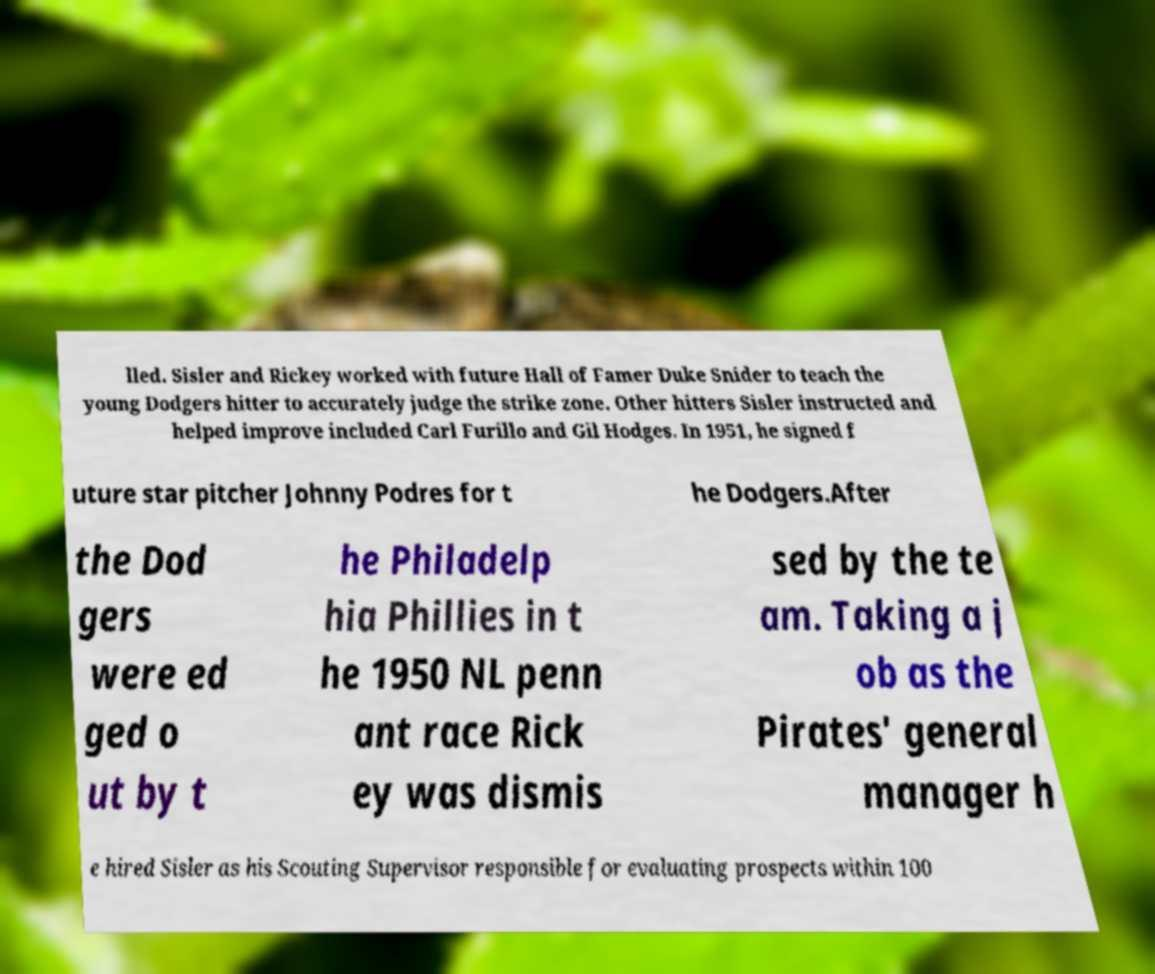Please identify and transcribe the text found in this image. lled. Sisler and Rickey worked with future Hall of Famer Duke Snider to teach the young Dodgers hitter to accurately judge the strike zone. Other hitters Sisler instructed and helped improve included Carl Furillo and Gil Hodges. In 1951, he signed f uture star pitcher Johnny Podres for t he Dodgers.After the Dod gers were ed ged o ut by t he Philadelp hia Phillies in t he 1950 NL penn ant race Rick ey was dismis sed by the te am. Taking a j ob as the Pirates' general manager h e hired Sisler as his Scouting Supervisor responsible for evaluating prospects within 100 